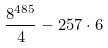<formula> <loc_0><loc_0><loc_500><loc_500>\frac { 8 ^ { 4 8 5 } } { 4 } - 2 5 7 \cdot 6</formula> 